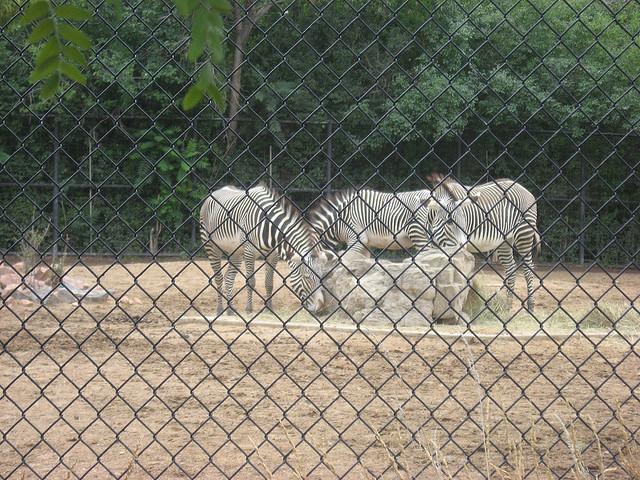Are the zebras adult zebras or baby zebras?
Keep it brief. Adult. Is one animal smaller than the other?
Write a very short answer. No. What type of fencing is in the scene?
Write a very short answer. Chain link. How many zebras are there?
Write a very short answer. 3. 